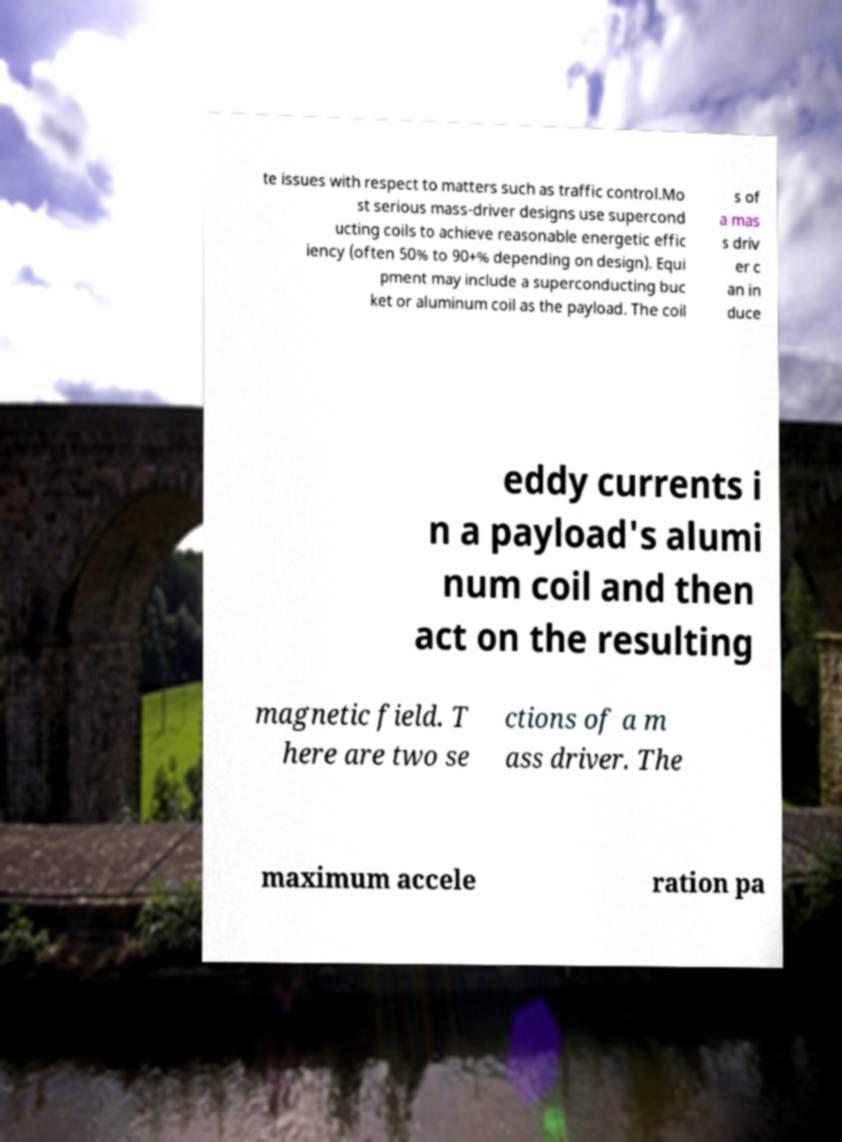Could you extract and type out the text from this image? te issues with respect to matters such as traffic control.Mo st serious mass-driver designs use supercond ucting coils to achieve reasonable energetic effic iency (often 50% to 90+% depending on design). Equi pment may include a superconducting buc ket or aluminum coil as the payload. The coil s of a mas s driv er c an in duce eddy currents i n a payload's alumi num coil and then act on the resulting magnetic field. T here are two se ctions of a m ass driver. The maximum accele ration pa 